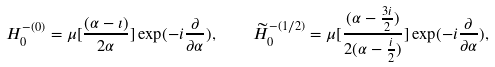<formula> <loc_0><loc_0><loc_500><loc_500>H ^ { - ( 0 ) } _ { 0 } = \mu [ \frac { ( \alpha - \imath ) } { 2 { \alpha } } ] \exp ( - i \frac { \partial } { { \partial } { \alpha } } ) , \quad \widetilde { H } ^ { - ( 1 / 2 ) } _ { 0 } = \mu [ \frac { ( \alpha - \frac { 3 i } { 2 } ) } { 2 ( { \alpha } - \frac { i } { 2 } ) } ] \exp ( - i \frac { \partial } { { \partial } { \alpha } } ) ,</formula> 